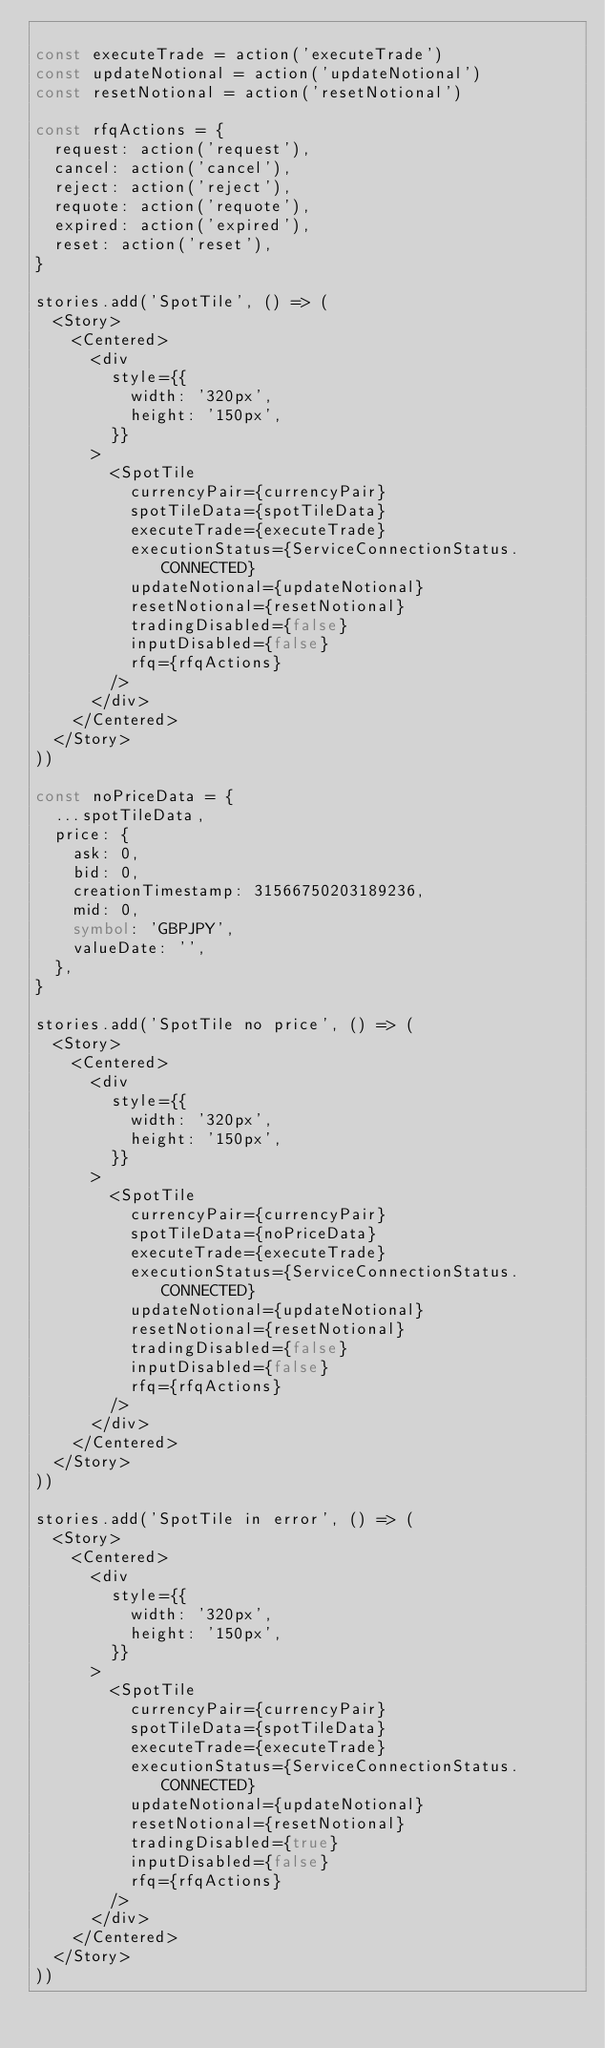Convert code to text. <code><loc_0><loc_0><loc_500><loc_500><_TypeScript_>
const executeTrade = action('executeTrade')
const updateNotional = action('updateNotional')
const resetNotional = action('resetNotional')

const rfqActions = {
  request: action('request'),
  cancel: action('cancel'),
  reject: action('reject'),
  requote: action('requote'),
  expired: action('expired'),
  reset: action('reset'),
}

stories.add('SpotTile', () => (
  <Story>
    <Centered>
      <div
        style={{
          width: '320px',
          height: '150px',
        }}
      >
        <SpotTile
          currencyPair={currencyPair}
          spotTileData={spotTileData}
          executeTrade={executeTrade}
          executionStatus={ServiceConnectionStatus.CONNECTED}
          updateNotional={updateNotional}
          resetNotional={resetNotional}
          tradingDisabled={false}
          inputDisabled={false}
          rfq={rfqActions}
        />
      </div>
    </Centered>
  </Story>
))

const noPriceData = {
  ...spotTileData,
  price: {
    ask: 0,
    bid: 0,
    creationTimestamp: 31566750203189236,
    mid: 0,
    symbol: 'GBPJPY',
    valueDate: '',
  },
}

stories.add('SpotTile no price', () => (
  <Story>
    <Centered>
      <div
        style={{
          width: '320px',
          height: '150px',
        }}
      >
        <SpotTile
          currencyPair={currencyPair}
          spotTileData={noPriceData}
          executeTrade={executeTrade}
          executionStatus={ServiceConnectionStatus.CONNECTED}
          updateNotional={updateNotional}
          resetNotional={resetNotional}
          tradingDisabled={false}
          inputDisabled={false}
          rfq={rfqActions}
        />
      </div>
    </Centered>
  </Story>
))

stories.add('SpotTile in error', () => (
  <Story>
    <Centered>
      <div
        style={{
          width: '320px',
          height: '150px',
        }}
      >
        <SpotTile
          currencyPair={currencyPair}
          spotTileData={spotTileData}
          executeTrade={executeTrade}
          executionStatus={ServiceConnectionStatus.CONNECTED}
          updateNotional={updateNotional}
          resetNotional={resetNotional}
          tradingDisabled={true}
          inputDisabled={false}
          rfq={rfqActions}
        />
      </div>
    </Centered>
  </Story>
))
</code> 